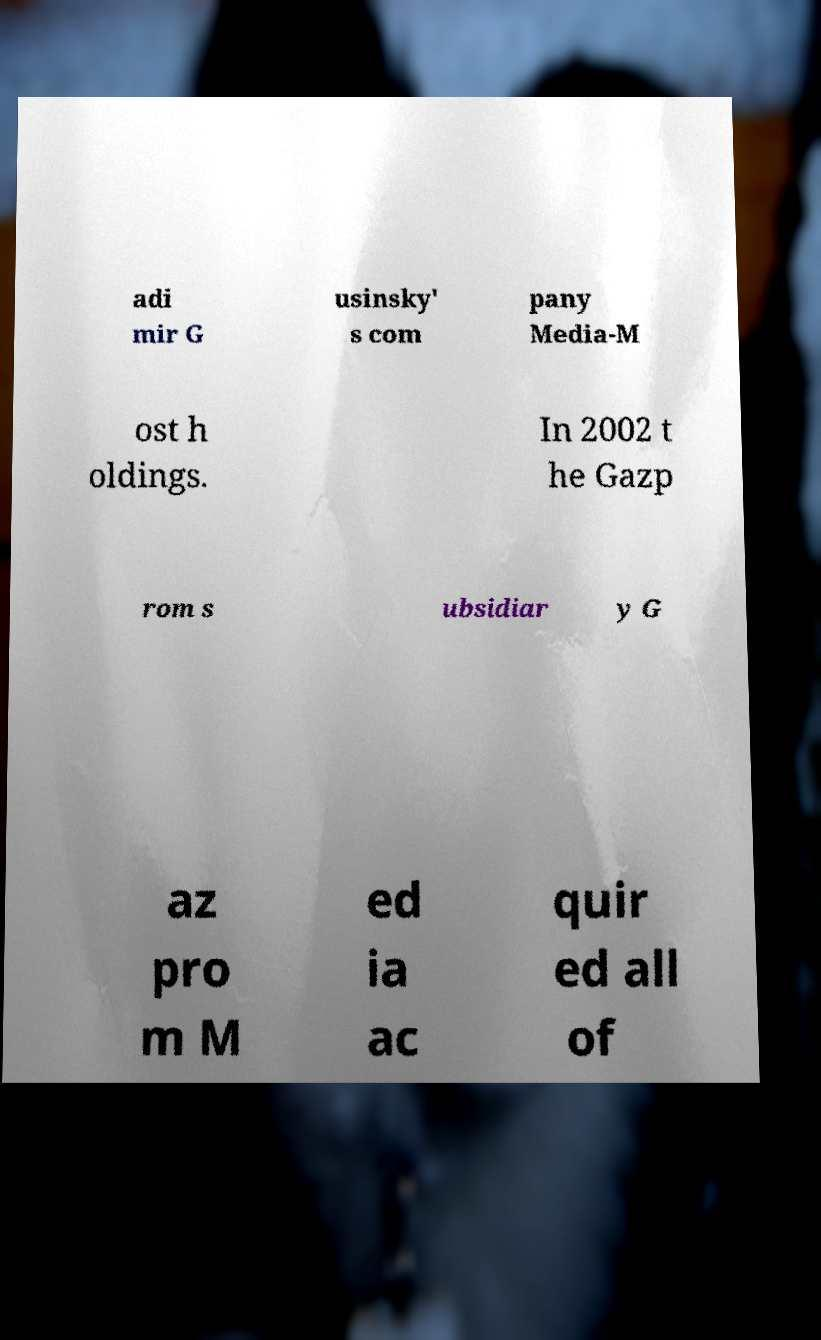Please read and relay the text visible in this image. What does it say? adi mir G usinsky' s com pany Media-M ost h oldings. In 2002 t he Gazp rom s ubsidiar y G az pro m M ed ia ac quir ed all of 